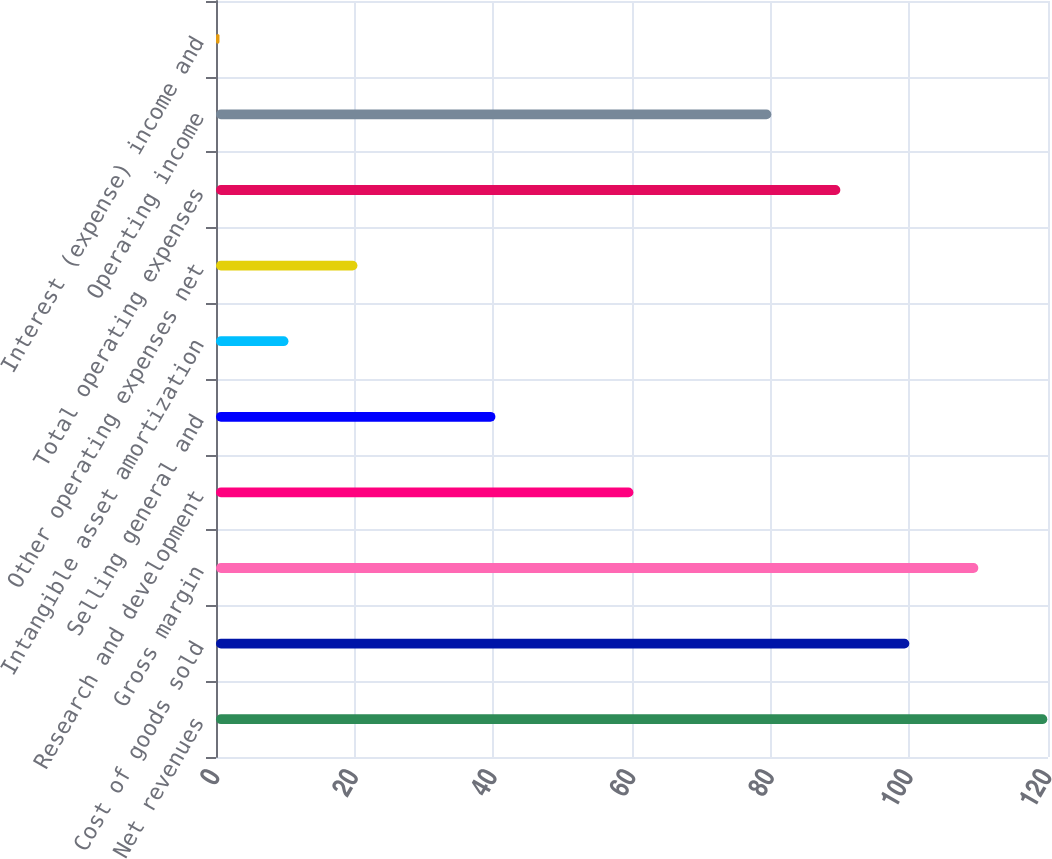Convert chart. <chart><loc_0><loc_0><loc_500><loc_500><bar_chart><fcel>Net revenues<fcel>Cost of goods sold<fcel>Gross margin<fcel>Research and development<fcel>Selling general and<fcel>Intangible asset amortization<fcel>Other operating expenses net<fcel>Total operating expenses<fcel>Operating income<fcel>Interest (expense) income and<nl><fcel>119.9<fcel>100<fcel>109.95<fcel>60.2<fcel>40.3<fcel>10.45<fcel>20.4<fcel>90.05<fcel>80.1<fcel>0.5<nl></chart> 